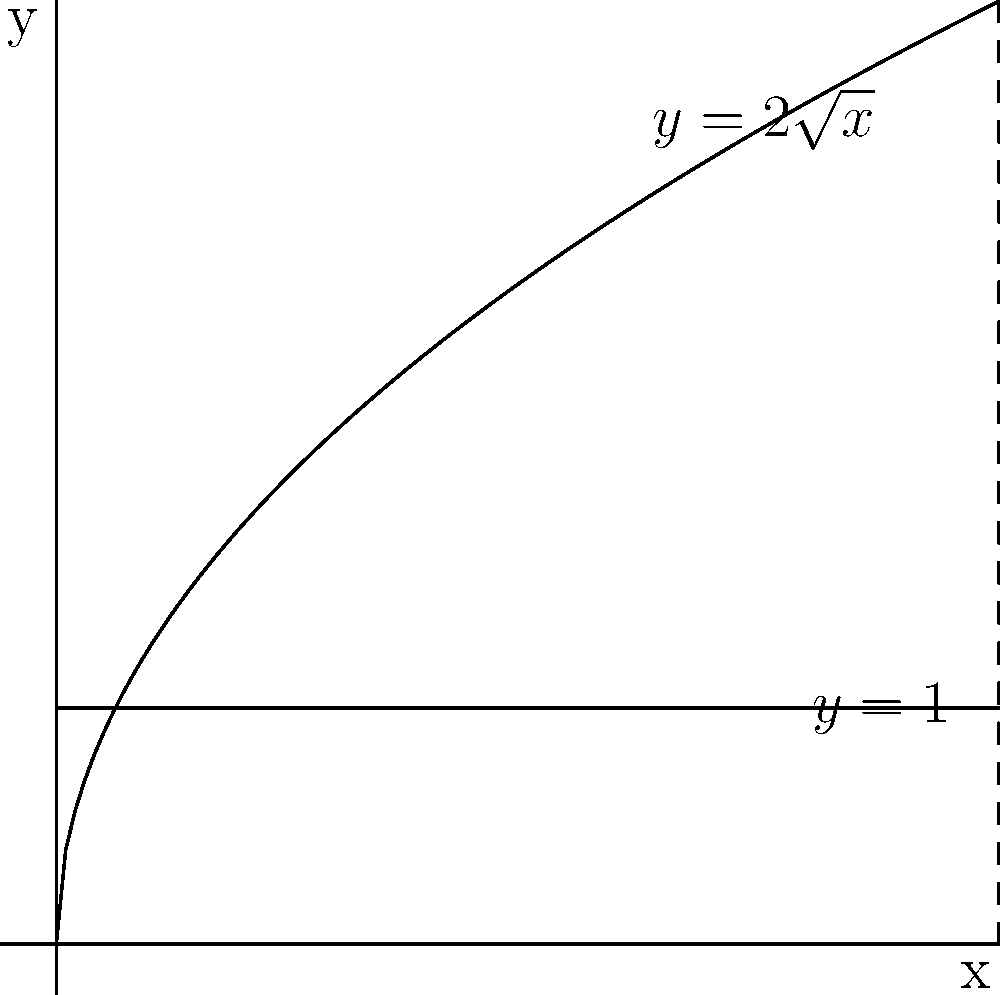As a film studies professor, you're explaining to your students how the shape of a film canister affects its volume. Consider a film canister whose cross-section is formed by rotating the region bounded by $y=2\sqrt{x}$, $y=1$, and the y-axis around the x-axis. Calculate the volume of this canister using the method of cylindrical shells. Let's approach this step-by-step:

1) The method of cylindrical shells uses the formula:
   $V = 2\pi \int_{a}^{b} r(y) \cdot h(y) \, dy$
   where $r(y)$ is the radius of each shell and $h(y)$ is its height.

2) In this case, we're rotating around the x-axis, so $y$ becomes our radius.
   The bounds are from $y=1$ to $y=2\sqrt{4}=4$ (the maximum height of the curve).

3) We need to express $x$ in terms of $y$:
   $y = 2\sqrt{x}$
   $y^2 = 4x$
   $x = \frac{y^2}{4}$

4) The radius of each shell is $y$, and the height is the difference between the curve and the line $x=4$:
   $h(y) = 4 - \frac{y^2}{4}$

5) Substituting into our volume formula:
   $V = 2\pi \int_{1}^{4} y \cdot (4 - \frac{y^2}{4}) \, dy$

6) Expanding:
   $V = 2\pi \int_{1}^{4} (4y - \frac{y^3}{4}) \, dy$

7) Integrating:
   $V = 2\pi [\frac{4y^2}{2} - \frac{y^4}{16}]_{1}^{4}$

8) Evaluating the limits:
   $V = 2\pi [(32 - 16) - (\frac{1}{2} - \frac{1}{16})]$
   $V = 2\pi [16 - \frac{7}{16}]$
   $V = 2\pi \cdot \frac{249}{16}$
   $V = \frac{249\pi}{8}$ cubic units

Therefore, the volume of the film canister is $\frac{249\pi}{8}$ cubic units.
Answer: $\frac{249\pi}{8}$ cubic units 